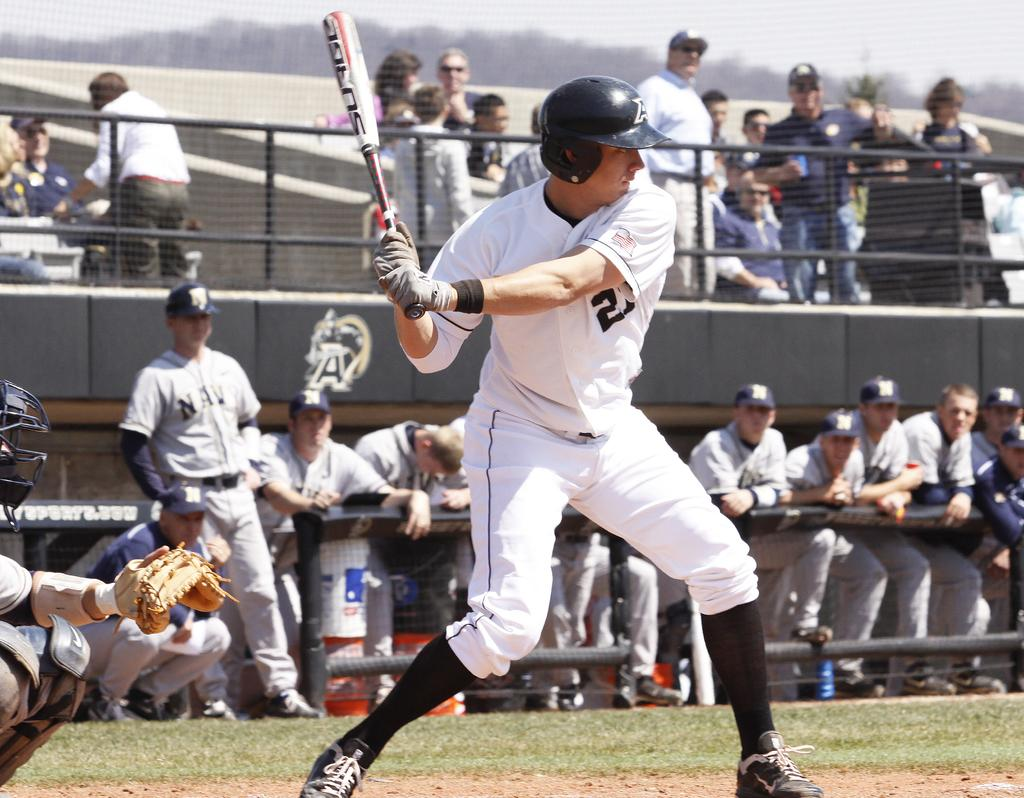What is the person in the image holding? The person in the image is holding a baseball bat. What can be seen in the background of the image? There are people standing in the stands in the background of the image. Can you see a snail crawling on the baseball bat in the image? No, there is no snail present on the baseball bat in the image. 